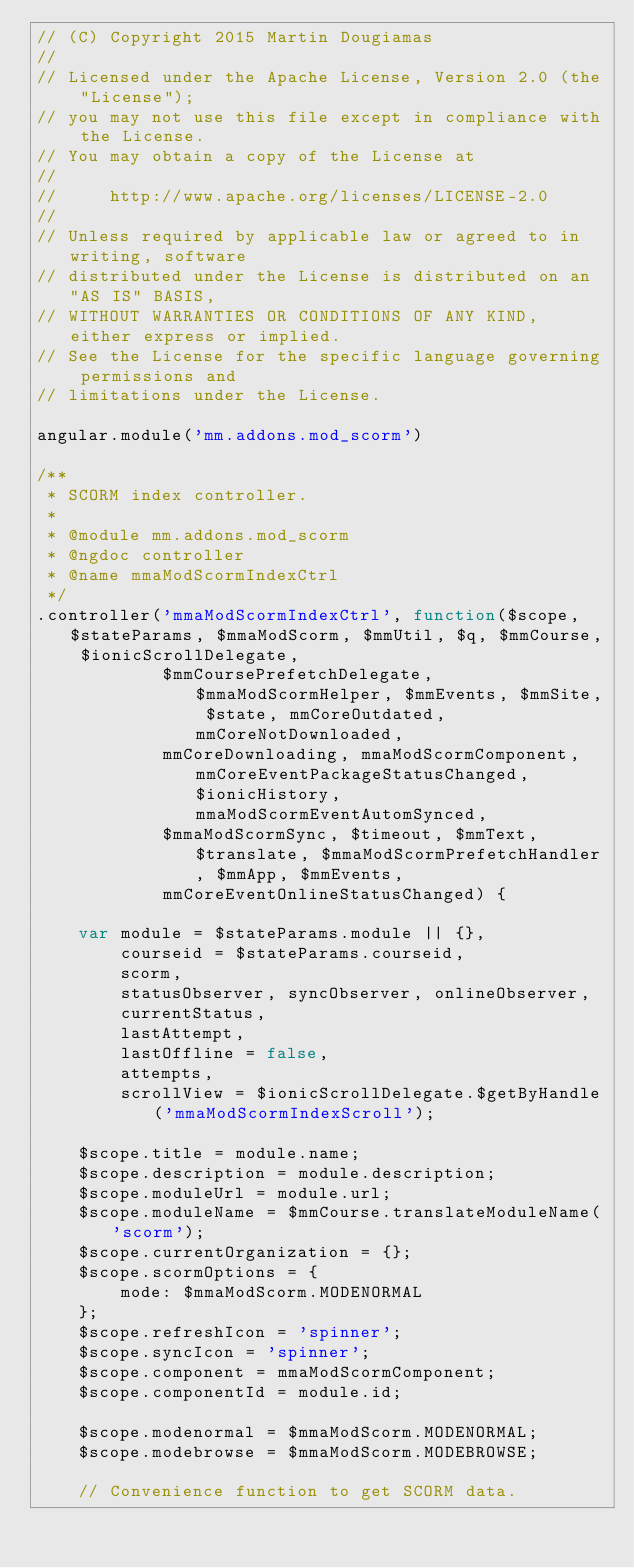Convert code to text. <code><loc_0><loc_0><loc_500><loc_500><_JavaScript_>// (C) Copyright 2015 Martin Dougiamas
//
// Licensed under the Apache License, Version 2.0 (the "License");
// you may not use this file except in compliance with the License.
// You may obtain a copy of the License at
//
//     http://www.apache.org/licenses/LICENSE-2.0
//
// Unless required by applicable law or agreed to in writing, software
// distributed under the License is distributed on an "AS IS" BASIS,
// WITHOUT WARRANTIES OR CONDITIONS OF ANY KIND, either express or implied.
// See the License for the specific language governing permissions and
// limitations under the License.

angular.module('mm.addons.mod_scorm')

/**
 * SCORM index controller.
 *
 * @module mm.addons.mod_scorm
 * @ngdoc controller
 * @name mmaModScormIndexCtrl
 */
.controller('mmaModScormIndexCtrl', function($scope, $stateParams, $mmaModScorm, $mmUtil, $q, $mmCourse, $ionicScrollDelegate,
            $mmCoursePrefetchDelegate, $mmaModScormHelper, $mmEvents, $mmSite, $state, mmCoreOutdated, mmCoreNotDownloaded,
            mmCoreDownloading, mmaModScormComponent, mmCoreEventPackageStatusChanged, $ionicHistory, mmaModScormEventAutomSynced,
            $mmaModScormSync, $timeout, $mmText, $translate, $mmaModScormPrefetchHandler, $mmApp, $mmEvents,
            mmCoreEventOnlineStatusChanged) {

    var module = $stateParams.module || {},
        courseid = $stateParams.courseid,
        scorm,
        statusObserver, syncObserver, onlineObserver,
        currentStatus,
        lastAttempt,
        lastOffline = false,
        attempts,
        scrollView = $ionicScrollDelegate.$getByHandle('mmaModScormIndexScroll');

    $scope.title = module.name;
    $scope.description = module.description;
    $scope.moduleUrl = module.url;
    $scope.moduleName = $mmCourse.translateModuleName('scorm');
    $scope.currentOrganization = {};
    $scope.scormOptions = {
        mode: $mmaModScorm.MODENORMAL
    };
    $scope.refreshIcon = 'spinner';
    $scope.syncIcon = 'spinner';
    $scope.component = mmaModScormComponent;
    $scope.componentId = module.id;

    $scope.modenormal = $mmaModScorm.MODENORMAL;
    $scope.modebrowse = $mmaModScorm.MODEBROWSE;

    // Convenience function to get SCORM data.</code> 